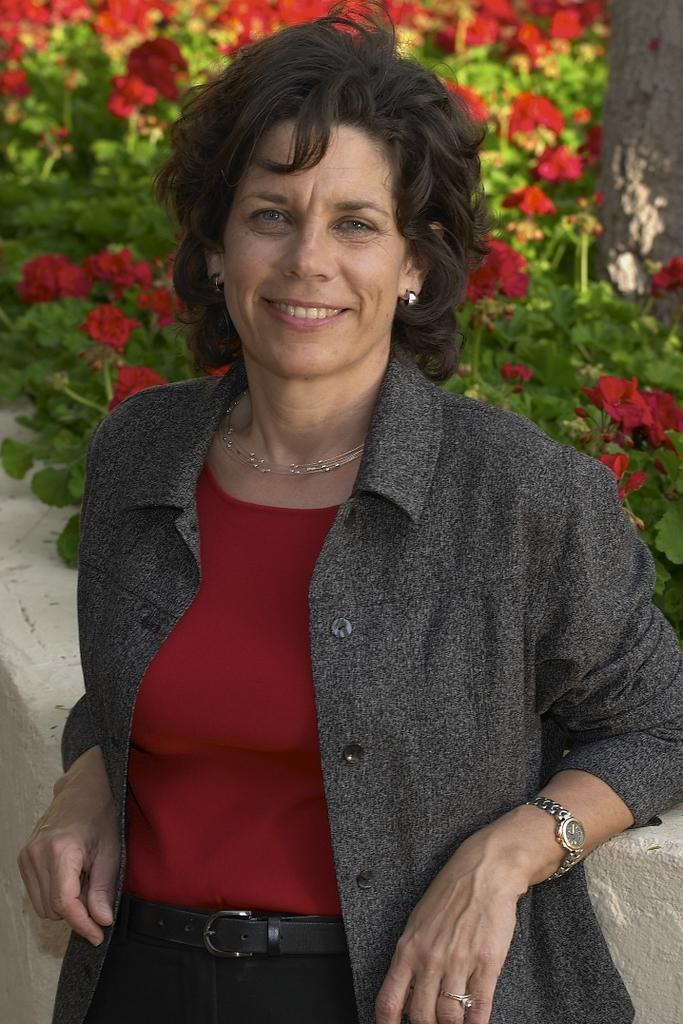In one or two sentences, can you explain what this image depicts? The woman in maroon T-shirt and black jacket is standing. She is smiling. Behind her, we see a white wall. Behind her, we see plants, which have flowers and these flowers are in red color. 